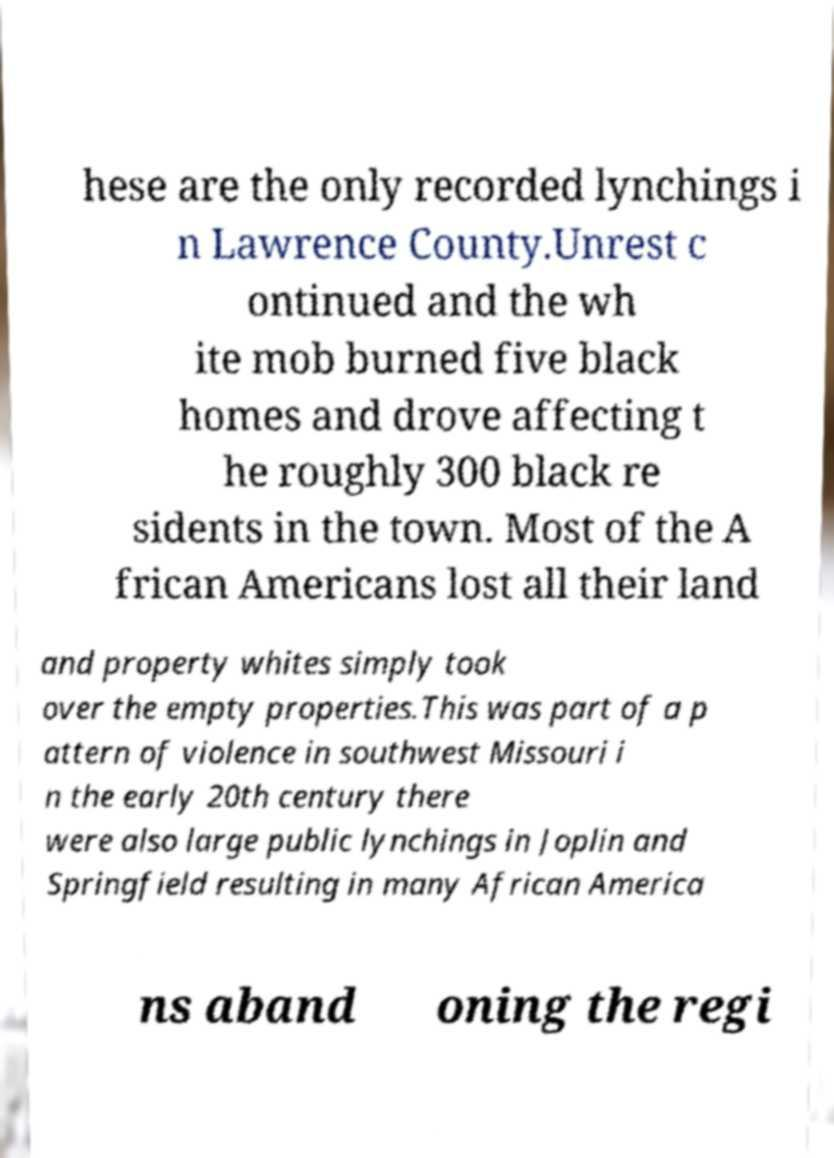What messages or text are displayed in this image? I need them in a readable, typed format. hese are the only recorded lynchings i n Lawrence County.Unrest c ontinued and the wh ite mob burned five black homes and drove affecting t he roughly 300 black re sidents in the town. Most of the A frican Americans lost all their land and property whites simply took over the empty properties.This was part of a p attern of violence in southwest Missouri i n the early 20th century there were also large public lynchings in Joplin and Springfield resulting in many African America ns aband oning the regi 